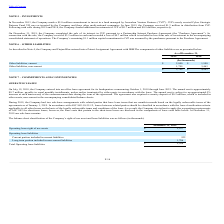From Finjan Holding's financial document, What are the respective values of other current liabilities in 2019 and 2018? The document shows two values: $2,000 and $1,500 (in thousands). From the document: "Other liabilities, current $ 2,000 $ 1,500 Other liabilities, current $ 2,000 $ 1,500..." Also, What are the respective values of other non-current liabilities in 2019 and 2018? The document shows two values: 1,799 and 3,463 (in thousands). From the document: "Other liabilities, non-current 1,799 3,463 Other liabilities, non-current 1,799 3,463..." Also, What are the respective values of total other liabilities in 2019 and 2018? The document shows two values: $3,799 and $4,963 (in thousands). From the document: "$ 3,799 $ 4,963 $ 3,799 $ 4,963..." Also, can you calculate: What is the average other current liabilities in 2018 and 2019? To answer this question, I need to perform calculations using the financial data. The calculation is: (2,000+1,500)/2 , which equals 1750 (in thousands). This is based on the information: "Other liabilities, current $ 2,000 $ 1,500 Other liabilities, current $ 2,000 $ 1,500..." The key data points involved are: 1,500, 2,000. Also, can you calculate: What is the value of other current liabilities as a percentage of the total other liabilities in 2019? Based on the calculation: 2,000/3,799 , the result is 52.65 (percentage). This is based on the information: "Other liabilities, current $ 2,000 $ 1,500 $ 3,799 $ 4,963..." The key data points involved are: 2,000, 3,799. Also, can you calculate: What is the average total other liabilities in 2018 and 2019? To answer this question, I need to perform calculations using the financial data. The calculation is: (3,799 + 4,963)/2 , which equals 4381 (in thousands). This is based on the information: "$ 3,799 $ 4,963 $ 3,799 $ 4,963..." The key data points involved are: 3,799, 4,963. 